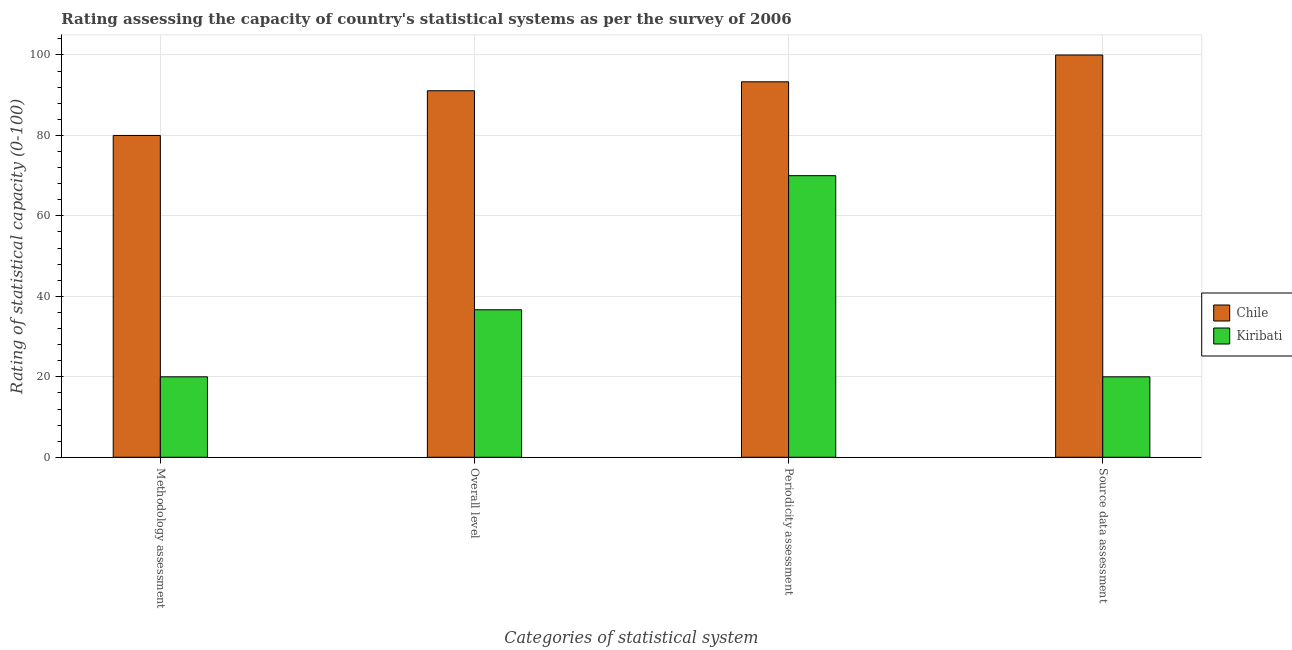Are the number of bars per tick equal to the number of legend labels?
Your answer should be compact. Yes. How many bars are there on the 1st tick from the left?
Your response must be concise. 2. What is the label of the 2nd group of bars from the left?
Offer a very short reply. Overall level. What is the source data assessment rating in Chile?
Offer a terse response. 100. Across all countries, what is the minimum overall level rating?
Provide a short and direct response. 36.67. In which country was the methodology assessment rating maximum?
Make the answer very short. Chile. In which country was the periodicity assessment rating minimum?
Offer a very short reply. Kiribati. What is the total overall level rating in the graph?
Provide a succinct answer. 127.78. What is the difference between the periodicity assessment rating in Chile and that in Kiribati?
Keep it short and to the point. 23.33. What is the difference between the source data assessment rating in Kiribati and the overall level rating in Chile?
Offer a terse response. -71.11. What is the average overall level rating per country?
Ensure brevity in your answer.  63.89. What is the difference between the source data assessment rating and methodology assessment rating in Chile?
Keep it short and to the point. 20. What is the ratio of the periodicity assessment rating in Kiribati to that in Chile?
Provide a short and direct response. 0.75. Is the difference between the overall level rating in Chile and Kiribati greater than the difference between the periodicity assessment rating in Chile and Kiribati?
Give a very brief answer. Yes. What is the difference between the highest and the second highest periodicity assessment rating?
Give a very brief answer. 23.33. Is it the case that in every country, the sum of the periodicity assessment rating and overall level rating is greater than the sum of methodology assessment rating and source data assessment rating?
Provide a succinct answer. No. What does the 2nd bar from the left in Methodology assessment represents?
Your response must be concise. Kiribati. What does the 2nd bar from the right in Methodology assessment represents?
Your answer should be compact. Chile. Is it the case that in every country, the sum of the methodology assessment rating and overall level rating is greater than the periodicity assessment rating?
Provide a short and direct response. No. Are all the bars in the graph horizontal?
Provide a succinct answer. No. What is the difference between two consecutive major ticks on the Y-axis?
Make the answer very short. 20. Does the graph contain any zero values?
Give a very brief answer. No. Where does the legend appear in the graph?
Give a very brief answer. Center right. How are the legend labels stacked?
Keep it short and to the point. Vertical. What is the title of the graph?
Your response must be concise. Rating assessing the capacity of country's statistical systems as per the survey of 2006 . What is the label or title of the X-axis?
Offer a very short reply. Categories of statistical system. What is the label or title of the Y-axis?
Offer a very short reply. Rating of statistical capacity (0-100). What is the Rating of statistical capacity (0-100) of Chile in Methodology assessment?
Make the answer very short. 80. What is the Rating of statistical capacity (0-100) of Chile in Overall level?
Offer a very short reply. 91.11. What is the Rating of statistical capacity (0-100) of Kiribati in Overall level?
Your answer should be very brief. 36.67. What is the Rating of statistical capacity (0-100) in Chile in Periodicity assessment?
Provide a succinct answer. 93.33. What is the Rating of statistical capacity (0-100) of Chile in Source data assessment?
Ensure brevity in your answer.  100. What is the Rating of statistical capacity (0-100) in Kiribati in Source data assessment?
Keep it short and to the point. 20. Across all Categories of statistical system, what is the minimum Rating of statistical capacity (0-100) in Kiribati?
Ensure brevity in your answer.  20. What is the total Rating of statistical capacity (0-100) in Chile in the graph?
Make the answer very short. 364.44. What is the total Rating of statistical capacity (0-100) in Kiribati in the graph?
Keep it short and to the point. 146.67. What is the difference between the Rating of statistical capacity (0-100) in Chile in Methodology assessment and that in Overall level?
Offer a very short reply. -11.11. What is the difference between the Rating of statistical capacity (0-100) of Kiribati in Methodology assessment and that in Overall level?
Offer a very short reply. -16.67. What is the difference between the Rating of statistical capacity (0-100) in Chile in Methodology assessment and that in Periodicity assessment?
Give a very brief answer. -13.33. What is the difference between the Rating of statistical capacity (0-100) in Kiribati in Methodology assessment and that in Periodicity assessment?
Give a very brief answer. -50. What is the difference between the Rating of statistical capacity (0-100) in Chile in Overall level and that in Periodicity assessment?
Provide a short and direct response. -2.22. What is the difference between the Rating of statistical capacity (0-100) of Kiribati in Overall level and that in Periodicity assessment?
Give a very brief answer. -33.33. What is the difference between the Rating of statistical capacity (0-100) in Chile in Overall level and that in Source data assessment?
Your answer should be compact. -8.89. What is the difference between the Rating of statistical capacity (0-100) in Kiribati in Overall level and that in Source data assessment?
Your response must be concise. 16.67. What is the difference between the Rating of statistical capacity (0-100) in Chile in Periodicity assessment and that in Source data assessment?
Give a very brief answer. -6.67. What is the difference between the Rating of statistical capacity (0-100) in Kiribati in Periodicity assessment and that in Source data assessment?
Make the answer very short. 50. What is the difference between the Rating of statistical capacity (0-100) of Chile in Methodology assessment and the Rating of statistical capacity (0-100) of Kiribati in Overall level?
Offer a terse response. 43.33. What is the difference between the Rating of statistical capacity (0-100) of Chile in Overall level and the Rating of statistical capacity (0-100) of Kiribati in Periodicity assessment?
Keep it short and to the point. 21.11. What is the difference between the Rating of statistical capacity (0-100) in Chile in Overall level and the Rating of statistical capacity (0-100) in Kiribati in Source data assessment?
Offer a very short reply. 71.11. What is the difference between the Rating of statistical capacity (0-100) in Chile in Periodicity assessment and the Rating of statistical capacity (0-100) in Kiribati in Source data assessment?
Make the answer very short. 73.33. What is the average Rating of statistical capacity (0-100) of Chile per Categories of statistical system?
Make the answer very short. 91.11. What is the average Rating of statistical capacity (0-100) of Kiribati per Categories of statistical system?
Provide a succinct answer. 36.67. What is the difference between the Rating of statistical capacity (0-100) in Chile and Rating of statistical capacity (0-100) in Kiribati in Overall level?
Your answer should be compact. 54.44. What is the difference between the Rating of statistical capacity (0-100) in Chile and Rating of statistical capacity (0-100) in Kiribati in Periodicity assessment?
Your answer should be very brief. 23.33. What is the ratio of the Rating of statistical capacity (0-100) of Chile in Methodology assessment to that in Overall level?
Make the answer very short. 0.88. What is the ratio of the Rating of statistical capacity (0-100) in Kiribati in Methodology assessment to that in Overall level?
Give a very brief answer. 0.55. What is the ratio of the Rating of statistical capacity (0-100) of Kiribati in Methodology assessment to that in Periodicity assessment?
Provide a short and direct response. 0.29. What is the ratio of the Rating of statistical capacity (0-100) in Kiribati in Methodology assessment to that in Source data assessment?
Your response must be concise. 1. What is the ratio of the Rating of statistical capacity (0-100) in Chile in Overall level to that in Periodicity assessment?
Make the answer very short. 0.98. What is the ratio of the Rating of statistical capacity (0-100) in Kiribati in Overall level to that in Periodicity assessment?
Your answer should be very brief. 0.52. What is the ratio of the Rating of statistical capacity (0-100) in Chile in Overall level to that in Source data assessment?
Your answer should be very brief. 0.91. What is the ratio of the Rating of statistical capacity (0-100) of Kiribati in Overall level to that in Source data assessment?
Your response must be concise. 1.83. What is the difference between the highest and the second highest Rating of statistical capacity (0-100) in Chile?
Provide a short and direct response. 6.67. What is the difference between the highest and the second highest Rating of statistical capacity (0-100) of Kiribati?
Offer a terse response. 33.33. What is the difference between the highest and the lowest Rating of statistical capacity (0-100) in Chile?
Your answer should be very brief. 20. What is the difference between the highest and the lowest Rating of statistical capacity (0-100) of Kiribati?
Provide a succinct answer. 50. 